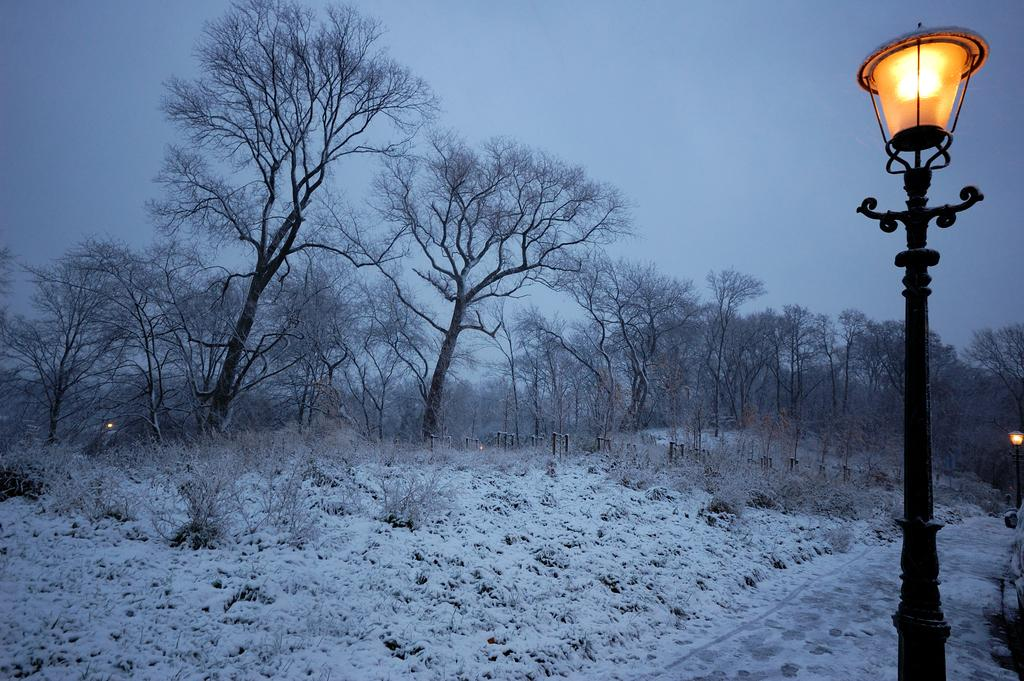What type of natural elements can be seen in the image? There are trees and plants in the image. What is the condition of the land in the image? The land is covered with snow. What type of artificial lighting is present in the image? There are street lights on the right side of the image. What is visible at the top of the image? The sky is visible at the top of the image. What type of downtown detail can be seen in the image? There is no downtown detail present in the image; it features trees, plants, snow-covered land, street lights, and the sky. How many lights are visible in the image? The question cannot be answered definitively, as the number of lights visible in the image is not specified in the provided facts. 